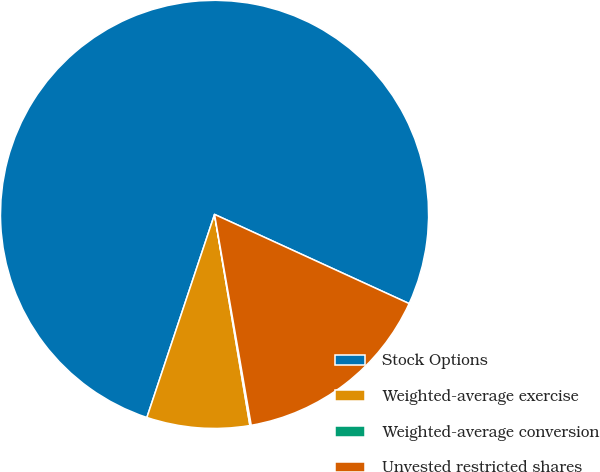Convert chart. <chart><loc_0><loc_0><loc_500><loc_500><pie_chart><fcel>Stock Options<fcel>Weighted-average exercise<fcel>Weighted-average conversion<fcel>Unvested restricted shares<nl><fcel>76.72%<fcel>7.76%<fcel>0.1%<fcel>15.42%<nl></chart> 